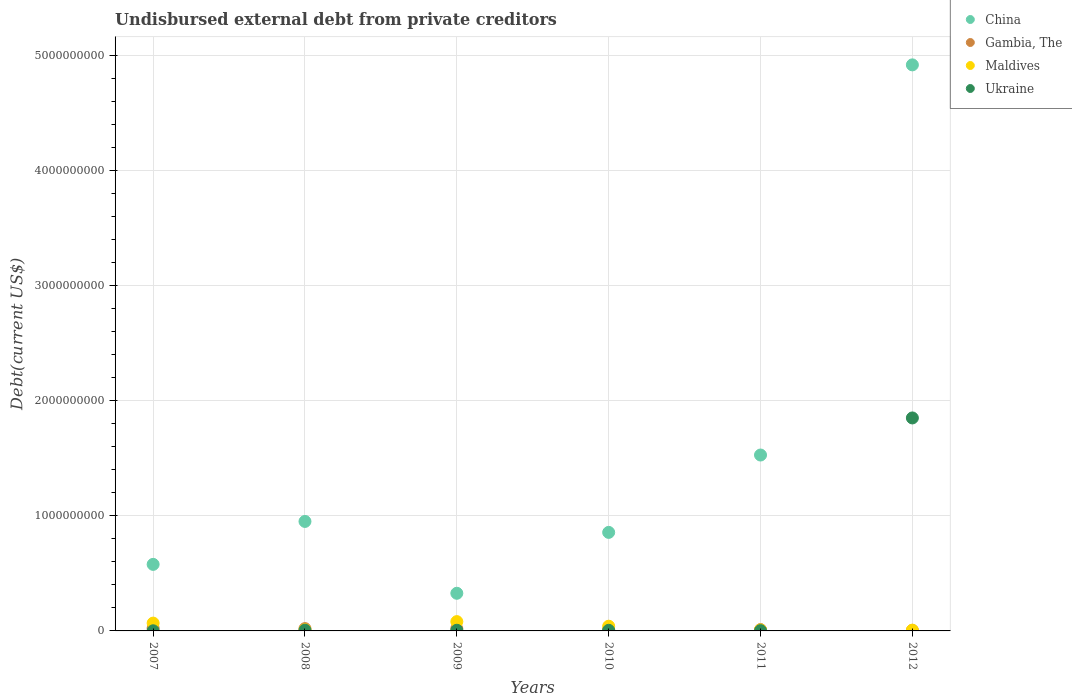What is the total debt in Maldives in 2012?
Your answer should be very brief. 6.80e+06. Across all years, what is the maximum total debt in Ukraine?
Ensure brevity in your answer.  1.85e+09. Across all years, what is the minimum total debt in Maldives?
Your response must be concise. 6.80e+06. In which year was the total debt in Ukraine maximum?
Keep it short and to the point. 2012. What is the total total debt in Maldives in the graph?
Your response must be concise. 2.15e+08. What is the difference between the total debt in Ukraine in 2008 and that in 2010?
Your response must be concise. 1.29e+06. What is the difference between the total debt in Ukraine in 2010 and the total debt in Maldives in 2012?
Your response must be concise. -1.45e+06. What is the average total debt in Ukraine per year?
Provide a short and direct response. 3.12e+08. In the year 2010, what is the difference between the total debt in Ukraine and total debt in Maldives?
Provide a short and direct response. -3.56e+07. What is the ratio of the total debt in Maldives in 2007 to that in 2008?
Your answer should be very brief. 7. Is the difference between the total debt in Ukraine in 2008 and 2011 greater than the difference between the total debt in Maldives in 2008 and 2011?
Offer a terse response. Yes. What is the difference between the highest and the second highest total debt in Maldives?
Offer a terse response. 1.30e+07. What is the difference between the highest and the lowest total debt in Ukraine?
Your answer should be compact. 1.85e+09. In how many years, is the total debt in China greater than the average total debt in China taken over all years?
Make the answer very short. 2. Is it the case that in every year, the sum of the total debt in Ukraine and total debt in Maldives  is greater than the total debt in Gambia, The?
Give a very brief answer. No. Does the total debt in Ukraine monotonically increase over the years?
Your answer should be compact. No. Is the total debt in Maldives strictly greater than the total debt in China over the years?
Your answer should be compact. No. How many dotlines are there?
Your answer should be compact. 4. How many years are there in the graph?
Provide a succinct answer. 6. Are the values on the major ticks of Y-axis written in scientific E-notation?
Provide a short and direct response. No. What is the title of the graph?
Offer a very short reply. Undisbursed external debt from private creditors. Does "Arab World" appear as one of the legend labels in the graph?
Make the answer very short. No. What is the label or title of the Y-axis?
Your answer should be compact. Debt(current US$). What is the Debt(current US$) in China in 2007?
Give a very brief answer. 5.78e+08. What is the Debt(current US$) of Gambia, The in 2007?
Provide a short and direct response. 2.39e+07. What is the Debt(current US$) in Maldives in 2007?
Give a very brief answer. 6.79e+07. What is the Debt(current US$) in Ukraine in 2007?
Your answer should be compact. 1.13e+06. What is the Debt(current US$) in China in 2008?
Your answer should be very brief. 9.51e+08. What is the Debt(current US$) in Gambia, The in 2008?
Provide a short and direct response. 2.01e+07. What is the Debt(current US$) in Maldives in 2008?
Provide a short and direct response. 9.70e+06. What is the Debt(current US$) in Ukraine in 2008?
Make the answer very short. 6.63e+06. What is the Debt(current US$) of China in 2009?
Offer a terse response. 3.27e+08. What is the Debt(current US$) in Gambia, The in 2009?
Offer a very short reply. 2.00e+07. What is the Debt(current US$) of Maldives in 2009?
Your response must be concise. 8.09e+07. What is the Debt(current US$) in Ukraine in 2009?
Your response must be concise. 5.76e+06. What is the Debt(current US$) of China in 2010?
Keep it short and to the point. 8.56e+08. What is the Debt(current US$) in Gambia, The in 2010?
Your response must be concise. 1.21e+07. What is the Debt(current US$) in Maldives in 2010?
Ensure brevity in your answer.  4.10e+07. What is the Debt(current US$) of Ukraine in 2010?
Provide a succinct answer. 5.34e+06. What is the Debt(current US$) of China in 2011?
Give a very brief answer. 1.53e+09. What is the Debt(current US$) in Gambia, The in 2011?
Keep it short and to the point. 1.17e+07. What is the Debt(current US$) of Maldives in 2011?
Your answer should be compact. 8.25e+06. What is the Debt(current US$) of Ukraine in 2011?
Provide a short and direct response. 2.59e+06. What is the Debt(current US$) in China in 2012?
Provide a succinct answer. 4.92e+09. What is the Debt(current US$) in Gambia, The in 2012?
Provide a short and direct response. 4.34e+06. What is the Debt(current US$) of Maldives in 2012?
Your response must be concise. 6.80e+06. What is the Debt(current US$) in Ukraine in 2012?
Offer a terse response. 1.85e+09. Across all years, what is the maximum Debt(current US$) of China?
Provide a short and direct response. 4.92e+09. Across all years, what is the maximum Debt(current US$) in Gambia, The?
Give a very brief answer. 2.39e+07. Across all years, what is the maximum Debt(current US$) of Maldives?
Ensure brevity in your answer.  8.09e+07. Across all years, what is the maximum Debt(current US$) in Ukraine?
Your answer should be very brief. 1.85e+09. Across all years, what is the minimum Debt(current US$) of China?
Your answer should be compact. 3.27e+08. Across all years, what is the minimum Debt(current US$) of Gambia, The?
Provide a succinct answer. 4.34e+06. Across all years, what is the minimum Debt(current US$) in Maldives?
Offer a terse response. 6.80e+06. Across all years, what is the minimum Debt(current US$) of Ukraine?
Your answer should be compact. 1.13e+06. What is the total Debt(current US$) of China in the graph?
Give a very brief answer. 9.16e+09. What is the total Debt(current US$) of Gambia, The in the graph?
Provide a short and direct response. 9.21e+07. What is the total Debt(current US$) of Maldives in the graph?
Provide a short and direct response. 2.15e+08. What is the total Debt(current US$) in Ukraine in the graph?
Your answer should be very brief. 1.87e+09. What is the difference between the Debt(current US$) of China in 2007 and that in 2008?
Offer a terse response. -3.73e+08. What is the difference between the Debt(current US$) in Gambia, The in 2007 and that in 2008?
Provide a succinct answer. 3.83e+06. What is the difference between the Debt(current US$) in Maldives in 2007 and that in 2008?
Make the answer very short. 5.82e+07. What is the difference between the Debt(current US$) of Ukraine in 2007 and that in 2008?
Offer a terse response. -5.50e+06. What is the difference between the Debt(current US$) in China in 2007 and that in 2009?
Make the answer very short. 2.51e+08. What is the difference between the Debt(current US$) in Gambia, The in 2007 and that in 2009?
Offer a very short reply. 3.94e+06. What is the difference between the Debt(current US$) in Maldives in 2007 and that in 2009?
Offer a very short reply. -1.30e+07. What is the difference between the Debt(current US$) of Ukraine in 2007 and that in 2009?
Provide a short and direct response. -4.63e+06. What is the difference between the Debt(current US$) of China in 2007 and that in 2010?
Make the answer very short. -2.78e+08. What is the difference between the Debt(current US$) of Gambia, The in 2007 and that in 2010?
Offer a terse response. 1.18e+07. What is the difference between the Debt(current US$) in Maldives in 2007 and that in 2010?
Your answer should be compact. 2.70e+07. What is the difference between the Debt(current US$) of Ukraine in 2007 and that in 2010?
Ensure brevity in your answer.  -4.22e+06. What is the difference between the Debt(current US$) in China in 2007 and that in 2011?
Provide a short and direct response. -9.50e+08. What is the difference between the Debt(current US$) in Gambia, The in 2007 and that in 2011?
Provide a short and direct response. 1.22e+07. What is the difference between the Debt(current US$) of Maldives in 2007 and that in 2011?
Make the answer very short. 5.97e+07. What is the difference between the Debt(current US$) in Ukraine in 2007 and that in 2011?
Make the answer very short. -1.46e+06. What is the difference between the Debt(current US$) in China in 2007 and that in 2012?
Your answer should be very brief. -4.34e+09. What is the difference between the Debt(current US$) of Gambia, The in 2007 and that in 2012?
Your response must be concise. 1.96e+07. What is the difference between the Debt(current US$) of Maldives in 2007 and that in 2012?
Ensure brevity in your answer.  6.11e+07. What is the difference between the Debt(current US$) in Ukraine in 2007 and that in 2012?
Make the answer very short. -1.85e+09. What is the difference between the Debt(current US$) in China in 2008 and that in 2009?
Your answer should be very brief. 6.24e+08. What is the difference between the Debt(current US$) in Gambia, The in 2008 and that in 2009?
Your answer should be compact. 1.05e+05. What is the difference between the Debt(current US$) in Maldives in 2008 and that in 2009?
Give a very brief answer. -7.12e+07. What is the difference between the Debt(current US$) of Ukraine in 2008 and that in 2009?
Ensure brevity in your answer.  8.71e+05. What is the difference between the Debt(current US$) of China in 2008 and that in 2010?
Give a very brief answer. 9.51e+07. What is the difference between the Debt(current US$) of Gambia, The in 2008 and that in 2010?
Offer a terse response. 8.01e+06. What is the difference between the Debt(current US$) of Maldives in 2008 and that in 2010?
Your answer should be compact. -3.13e+07. What is the difference between the Debt(current US$) of Ukraine in 2008 and that in 2010?
Your answer should be compact. 1.29e+06. What is the difference between the Debt(current US$) in China in 2008 and that in 2011?
Provide a short and direct response. -5.77e+08. What is the difference between the Debt(current US$) in Gambia, The in 2008 and that in 2011?
Offer a terse response. 8.40e+06. What is the difference between the Debt(current US$) in Maldives in 2008 and that in 2011?
Provide a succinct answer. 1.45e+06. What is the difference between the Debt(current US$) in Ukraine in 2008 and that in 2011?
Provide a succinct answer. 4.04e+06. What is the difference between the Debt(current US$) in China in 2008 and that in 2012?
Your answer should be compact. -3.97e+09. What is the difference between the Debt(current US$) of Gambia, The in 2008 and that in 2012?
Offer a terse response. 1.58e+07. What is the difference between the Debt(current US$) of Maldives in 2008 and that in 2012?
Provide a succinct answer. 2.91e+06. What is the difference between the Debt(current US$) of Ukraine in 2008 and that in 2012?
Your response must be concise. -1.84e+09. What is the difference between the Debt(current US$) of China in 2009 and that in 2010?
Offer a very short reply. -5.29e+08. What is the difference between the Debt(current US$) of Gambia, The in 2009 and that in 2010?
Your answer should be very brief. 7.91e+06. What is the difference between the Debt(current US$) of Maldives in 2009 and that in 2010?
Ensure brevity in your answer.  3.99e+07. What is the difference between the Debt(current US$) in Ukraine in 2009 and that in 2010?
Provide a short and direct response. 4.17e+05. What is the difference between the Debt(current US$) in China in 2009 and that in 2011?
Your response must be concise. -1.20e+09. What is the difference between the Debt(current US$) in Gambia, The in 2009 and that in 2011?
Ensure brevity in your answer.  8.29e+06. What is the difference between the Debt(current US$) in Maldives in 2009 and that in 2011?
Your answer should be compact. 7.26e+07. What is the difference between the Debt(current US$) of Ukraine in 2009 and that in 2011?
Make the answer very short. 3.17e+06. What is the difference between the Debt(current US$) in China in 2009 and that in 2012?
Offer a terse response. -4.59e+09. What is the difference between the Debt(current US$) in Gambia, The in 2009 and that in 2012?
Give a very brief answer. 1.57e+07. What is the difference between the Debt(current US$) in Maldives in 2009 and that in 2012?
Offer a terse response. 7.41e+07. What is the difference between the Debt(current US$) in Ukraine in 2009 and that in 2012?
Ensure brevity in your answer.  -1.84e+09. What is the difference between the Debt(current US$) of China in 2010 and that in 2011?
Your answer should be very brief. -6.72e+08. What is the difference between the Debt(current US$) of Gambia, The in 2010 and that in 2011?
Offer a terse response. 3.83e+05. What is the difference between the Debt(current US$) of Maldives in 2010 and that in 2011?
Offer a terse response. 3.27e+07. What is the difference between the Debt(current US$) of Ukraine in 2010 and that in 2011?
Ensure brevity in your answer.  2.76e+06. What is the difference between the Debt(current US$) of China in 2010 and that in 2012?
Keep it short and to the point. -4.06e+09. What is the difference between the Debt(current US$) of Gambia, The in 2010 and that in 2012?
Ensure brevity in your answer.  7.74e+06. What is the difference between the Debt(current US$) in Maldives in 2010 and that in 2012?
Your answer should be compact. 3.42e+07. What is the difference between the Debt(current US$) in Ukraine in 2010 and that in 2012?
Keep it short and to the point. -1.84e+09. What is the difference between the Debt(current US$) of China in 2011 and that in 2012?
Your answer should be very brief. -3.39e+09. What is the difference between the Debt(current US$) of Gambia, The in 2011 and that in 2012?
Give a very brief answer. 7.36e+06. What is the difference between the Debt(current US$) of Maldives in 2011 and that in 2012?
Offer a terse response. 1.46e+06. What is the difference between the Debt(current US$) of Ukraine in 2011 and that in 2012?
Your answer should be very brief. -1.85e+09. What is the difference between the Debt(current US$) of China in 2007 and the Debt(current US$) of Gambia, The in 2008?
Offer a terse response. 5.58e+08. What is the difference between the Debt(current US$) in China in 2007 and the Debt(current US$) in Maldives in 2008?
Ensure brevity in your answer.  5.68e+08. What is the difference between the Debt(current US$) in China in 2007 and the Debt(current US$) in Ukraine in 2008?
Your answer should be very brief. 5.71e+08. What is the difference between the Debt(current US$) in Gambia, The in 2007 and the Debt(current US$) in Maldives in 2008?
Keep it short and to the point. 1.42e+07. What is the difference between the Debt(current US$) of Gambia, The in 2007 and the Debt(current US$) of Ukraine in 2008?
Provide a short and direct response. 1.73e+07. What is the difference between the Debt(current US$) of Maldives in 2007 and the Debt(current US$) of Ukraine in 2008?
Make the answer very short. 6.13e+07. What is the difference between the Debt(current US$) of China in 2007 and the Debt(current US$) of Gambia, The in 2009?
Provide a short and direct response. 5.58e+08. What is the difference between the Debt(current US$) of China in 2007 and the Debt(current US$) of Maldives in 2009?
Give a very brief answer. 4.97e+08. What is the difference between the Debt(current US$) in China in 2007 and the Debt(current US$) in Ukraine in 2009?
Your answer should be compact. 5.72e+08. What is the difference between the Debt(current US$) of Gambia, The in 2007 and the Debt(current US$) of Maldives in 2009?
Offer a terse response. -5.70e+07. What is the difference between the Debt(current US$) of Gambia, The in 2007 and the Debt(current US$) of Ukraine in 2009?
Provide a short and direct response. 1.82e+07. What is the difference between the Debt(current US$) of Maldives in 2007 and the Debt(current US$) of Ukraine in 2009?
Offer a terse response. 6.22e+07. What is the difference between the Debt(current US$) in China in 2007 and the Debt(current US$) in Gambia, The in 2010?
Make the answer very short. 5.66e+08. What is the difference between the Debt(current US$) of China in 2007 and the Debt(current US$) of Maldives in 2010?
Your answer should be compact. 5.37e+08. What is the difference between the Debt(current US$) in China in 2007 and the Debt(current US$) in Ukraine in 2010?
Your answer should be very brief. 5.73e+08. What is the difference between the Debt(current US$) of Gambia, The in 2007 and the Debt(current US$) of Maldives in 2010?
Provide a succinct answer. -1.70e+07. What is the difference between the Debt(current US$) of Gambia, The in 2007 and the Debt(current US$) of Ukraine in 2010?
Your answer should be very brief. 1.86e+07. What is the difference between the Debt(current US$) in Maldives in 2007 and the Debt(current US$) in Ukraine in 2010?
Offer a very short reply. 6.26e+07. What is the difference between the Debt(current US$) in China in 2007 and the Debt(current US$) in Gambia, The in 2011?
Offer a very short reply. 5.66e+08. What is the difference between the Debt(current US$) of China in 2007 and the Debt(current US$) of Maldives in 2011?
Provide a short and direct response. 5.70e+08. What is the difference between the Debt(current US$) in China in 2007 and the Debt(current US$) in Ukraine in 2011?
Your answer should be compact. 5.75e+08. What is the difference between the Debt(current US$) in Gambia, The in 2007 and the Debt(current US$) in Maldives in 2011?
Your answer should be very brief. 1.57e+07. What is the difference between the Debt(current US$) in Gambia, The in 2007 and the Debt(current US$) in Ukraine in 2011?
Offer a very short reply. 2.13e+07. What is the difference between the Debt(current US$) of Maldives in 2007 and the Debt(current US$) of Ukraine in 2011?
Provide a short and direct response. 6.54e+07. What is the difference between the Debt(current US$) of China in 2007 and the Debt(current US$) of Gambia, The in 2012?
Offer a terse response. 5.74e+08. What is the difference between the Debt(current US$) in China in 2007 and the Debt(current US$) in Maldives in 2012?
Provide a short and direct response. 5.71e+08. What is the difference between the Debt(current US$) in China in 2007 and the Debt(current US$) in Ukraine in 2012?
Your answer should be very brief. -1.27e+09. What is the difference between the Debt(current US$) of Gambia, The in 2007 and the Debt(current US$) of Maldives in 2012?
Give a very brief answer. 1.71e+07. What is the difference between the Debt(current US$) in Gambia, The in 2007 and the Debt(current US$) in Ukraine in 2012?
Offer a very short reply. -1.83e+09. What is the difference between the Debt(current US$) in Maldives in 2007 and the Debt(current US$) in Ukraine in 2012?
Provide a succinct answer. -1.78e+09. What is the difference between the Debt(current US$) in China in 2008 and the Debt(current US$) in Gambia, The in 2009?
Offer a very short reply. 9.31e+08. What is the difference between the Debt(current US$) in China in 2008 and the Debt(current US$) in Maldives in 2009?
Offer a very short reply. 8.70e+08. What is the difference between the Debt(current US$) of China in 2008 and the Debt(current US$) of Ukraine in 2009?
Your answer should be very brief. 9.45e+08. What is the difference between the Debt(current US$) in Gambia, The in 2008 and the Debt(current US$) in Maldives in 2009?
Provide a succinct answer. -6.08e+07. What is the difference between the Debt(current US$) in Gambia, The in 2008 and the Debt(current US$) in Ukraine in 2009?
Provide a succinct answer. 1.43e+07. What is the difference between the Debt(current US$) of Maldives in 2008 and the Debt(current US$) of Ukraine in 2009?
Offer a very short reply. 3.94e+06. What is the difference between the Debt(current US$) of China in 2008 and the Debt(current US$) of Gambia, The in 2010?
Your answer should be very brief. 9.39e+08. What is the difference between the Debt(current US$) of China in 2008 and the Debt(current US$) of Maldives in 2010?
Offer a very short reply. 9.10e+08. What is the difference between the Debt(current US$) of China in 2008 and the Debt(current US$) of Ukraine in 2010?
Keep it short and to the point. 9.46e+08. What is the difference between the Debt(current US$) of Gambia, The in 2008 and the Debt(current US$) of Maldives in 2010?
Ensure brevity in your answer.  -2.09e+07. What is the difference between the Debt(current US$) of Gambia, The in 2008 and the Debt(current US$) of Ukraine in 2010?
Provide a short and direct response. 1.48e+07. What is the difference between the Debt(current US$) in Maldives in 2008 and the Debt(current US$) in Ukraine in 2010?
Give a very brief answer. 4.36e+06. What is the difference between the Debt(current US$) of China in 2008 and the Debt(current US$) of Gambia, The in 2011?
Give a very brief answer. 9.39e+08. What is the difference between the Debt(current US$) of China in 2008 and the Debt(current US$) of Maldives in 2011?
Give a very brief answer. 9.43e+08. What is the difference between the Debt(current US$) in China in 2008 and the Debt(current US$) in Ukraine in 2011?
Your response must be concise. 9.48e+08. What is the difference between the Debt(current US$) in Gambia, The in 2008 and the Debt(current US$) in Maldives in 2011?
Your answer should be very brief. 1.18e+07. What is the difference between the Debt(current US$) of Gambia, The in 2008 and the Debt(current US$) of Ukraine in 2011?
Keep it short and to the point. 1.75e+07. What is the difference between the Debt(current US$) in Maldives in 2008 and the Debt(current US$) in Ukraine in 2011?
Give a very brief answer. 7.12e+06. What is the difference between the Debt(current US$) in China in 2008 and the Debt(current US$) in Gambia, The in 2012?
Provide a succinct answer. 9.47e+08. What is the difference between the Debt(current US$) of China in 2008 and the Debt(current US$) of Maldives in 2012?
Your answer should be very brief. 9.44e+08. What is the difference between the Debt(current US$) in China in 2008 and the Debt(current US$) in Ukraine in 2012?
Offer a terse response. -8.99e+08. What is the difference between the Debt(current US$) of Gambia, The in 2008 and the Debt(current US$) of Maldives in 2012?
Your answer should be very brief. 1.33e+07. What is the difference between the Debt(current US$) in Gambia, The in 2008 and the Debt(current US$) in Ukraine in 2012?
Provide a succinct answer. -1.83e+09. What is the difference between the Debt(current US$) in Maldives in 2008 and the Debt(current US$) in Ukraine in 2012?
Your answer should be very brief. -1.84e+09. What is the difference between the Debt(current US$) in China in 2009 and the Debt(current US$) in Gambia, The in 2010?
Give a very brief answer. 3.15e+08. What is the difference between the Debt(current US$) of China in 2009 and the Debt(current US$) of Maldives in 2010?
Your response must be concise. 2.86e+08. What is the difference between the Debt(current US$) of China in 2009 and the Debt(current US$) of Ukraine in 2010?
Offer a terse response. 3.22e+08. What is the difference between the Debt(current US$) in Gambia, The in 2009 and the Debt(current US$) in Maldives in 2010?
Your answer should be very brief. -2.10e+07. What is the difference between the Debt(current US$) of Gambia, The in 2009 and the Debt(current US$) of Ukraine in 2010?
Give a very brief answer. 1.46e+07. What is the difference between the Debt(current US$) of Maldives in 2009 and the Debt(current US$) of Ukraine in 2010?
Your answer should be very brief. 7.56e+07. What is the difference between the Debt(current US$) in China in 2009 and the Debt(current US$) in Gambia, The in 2011?
Give a very brief answer. 3.15e+08. What is the difference between the Debt(current US$) in China in 2009 and the Debt(current US$) in Maldives in 2011?
Provide a succinct answer. 3.19e+08. What is the difference between the Debt(current US$) in China in 2009 and the Debt(current US$) in Ukraine in 2011?
Your answer should be compact. 3.24e+08. What is the difference between the Debt(current US$) in Gambia, The in 2009 and the Debt(current US$) in Maldives in 2011?
Keep it short and to the point. 1.17e+07. What is the difference between the Debt(current US$) of Gambia, The in 2009 and the Debt(current US$) of Ukraine in 2011?
Provide a short and direct response. 1.74e+07. What is the difference between the Debt(current US$) in Maldives in 2009 and the Debt(current US$) in Ukraine in 2011?
Ensure brevity in your answer.  7.83e+07. What is the difference between the Debt(current US$) in China in 2009 and the Debt(current US$) in Gambia, The in 2012?
Offer a terse response. 3.23e+08. What is the difference between the Debt(current US$) of China in 2009 and the Debt(current US$) of Maldives in 2012?
Provide a short and direct response. 3.20e+08. What is the difference between the Debt(current US$) of China in 2009 and the Debt(current US$) of Ukraine in 2012?
Offer a terse response. -1.52e+09. What is the difference between the Debt(current US$) in Gambia, The in 2009 and the Debt(current US$) in Maldives in 2012?
Provide a short and direct response. 1.32e+07. What is the difference between the Debt(current US$) in Gambia, The in 2009 and the Debt(current US$) in Ukraine in 2012?
Your response must be concise. -1.83e+09. What is the difference between the Debt(current US$) of Maldives in 2009 and the Debt(current US$) of Ukraine in 2012?
Your response must be concise. -1.77e+09. What is the difference between the Debt(current US$) in China in 2010 and the Debt(current US$) in Gambia, The in 2011?
Keep it short and to the point. 8.44e+08. What is the difference between the Debt(current US$) of China in 2010 and the Debt(current US$) of Maldives in 2011?
Make the answer very short. 8.48e+08. What is the difference between the Debt(current US$) in China in 2010 and the Debt(current US$) in Ukraine in 2011?
Make the answer very short. 8.53e+08. What is the difference between the Debt(current US$) in Gambia, The in 2010 and the Debt(current US$) in Maldives in 2011?
Keep it short and to the point. 3.83e+06. What is the difference between the Debt(current US$) of Gambia, The in 2010 and the Debt(current US$) of Ukraine in 2011?
Give a very brief answer. 9.49e+06. What is the difference between the Debt(current US$) of Maldives in 2010 and the Debt(current US$) of Ukraine in 2011?
Offer a very short reply. 3.84e+07. What is the difference between the Debt(current US$) of China in 2010 and the Debt(current US$) of Gambia, The in 2012?
Your answer should be compact. 8.52e+08. What is the difference between the Debt(current US$) of China in 2010 and the Debt(current US$) of Maldives in 2012?
Provide a succinct answer. 8.49e+08. What is the difference between the Debt(current US$) in China in 2010 and the Debt(current US$) in Ukraine in 2012?
Ensure brevity in your answer.  -9.94e+08. What is the difference between the Debt(current US$) of Gambia, The in 2010 and the Debt(current US$) of Maldives in 2012?
Ensure brevity in your answer.  5.29e+06. What is the difference between the Debt(current US$) of Gambia, The in 2010 and the Debt(current US$) of Ukraine in 2012?
Offer a terse response. -1.84e+09. What is the difference between the Debt(current US$) of Maldives in 2010 and the Debt(current US$) of Ukraine in 2012?
Provide a short and direct response. -1.81e+09. What is the difference between the Debt(current US$) in China in 2011 and the Debt(current US$) in Gambia, The in 2012?
Your response must be concise. 1.52e+09. What is the difference between the Debt(current US$) of China in 2011 and the Debt(current US$) of Maldives in 2012?
Your response must be concise. 1.52e+09. What is the difference between the Debt(current US$) in China in 2011 and the Debt(current US$) in Ukraine in 2012?
Your answer should be very brief. -3.22e+08. What is the difference between the Debt(current US$) in Gambia, The in 2011 and the Debt(current US$) in Maldives in 2012?
Your answer should be very brief. 4.90e+06. What is the difference between the Debt(current US$) in Gambia, The in 2011 and the Debt(current US$) in Ukraine in 2012?
Offer a terse response. -1.84e+09. What is the difference between the Debt(current US$) in Maldives in 2011 and the Debt(current US$) in Ukraine in 2012?
Offer a terse response. -1.84e+09. What is the average Debt(current US$) in China per year?
Give a very brief answer. 1.53e+09. What is the average Debt(current US$) of Gambia, The per year?
Your response must be concise. 1.54e+07. What is the average Debt(current US$) in Maldives per year?
Give a very brief answer. 3.58e+07. What is the average Debt(current US$) in Ukraine per year?
Ensure brevity in your answer.  3.12e+08. In the year 2007, what is the difference between the Debt(current US$) of China and Debt(current US$) of Gambia, The?
Ensure brevity in your answer.  5.54e+08. In the year 2007, what is the difference between the Debt(current US$) in China and Debt(current US$) in Maldives?
Ensure brevity in your answer.  5.10e+08. In the year 2007, what is the difference between the Debt(current US$) of China and Debt(current US$) of Ukraine?
Your answer should be compact. 5.77e+08. In the year 2007, what is the difference between the Debt(current US$) of Gambia, The and Debt(current US$) of Maldives?
Offer a terse response. -4.40e+07. In the year 2007, what is the difference between the Debt(current US$) in Gambia, The and Debt(current US$) in Ukraine?
Offer a terse response. 2.28e+07. In the year 2007, what is the difference between the Debt(current US$) of Maldives and Debt(current US$) of Ukraine?
Offer a very short reply. 6.68e+07. In the year 2008, what is the difference between the Debt(current US$) of China and Debt(current US$) of Gambia, The?
Make the answer very short. 9.31e+08. In the year 2008, what is the difference between the Debt(current US$) in China and Debt(current US$) in Maldives?
Your answer should be very brief. 9.41e+08. In the year 2008, what is the difference between the Debt(current US$) in China and Debt(current US$) in Ukraine?
Give a very brief answer. 9.44e+08. In the year 2008, what is the difference between the Debt(current US$) in Gambia, The and Debt(current US$) in Maldives?
Your answer should be very brief. 1.04e+07. In the year 2008, what is the difference between the Debt(current US$) of Gambia, The and Debt(current US$) of Ukraine?
Your answer should be compact. 1.35e+07. In the year 2008, what is the difference between the Debt(current US$) of Maldives and Debt(current US$) of Ukraine?
Ensure brevity in your answer.  3.07e+06. In the year 2009, what is the difference between the Debt(current US$) of China and Debt(current US$) of Gambia, The?
Give a very brief answer. 3.07e+08. In the year 2009, what is the difference between the Debt(current US$) in China and Debt(current US$) in Maldives?
Keep it short and to the point. 2.46e+08. In the year 2009, what is the difference between the Debt(current US$) in China and Debt(current US$) in Ukraine?
Keep it short and to the point. 3.21e+08. In the year 2009, what is the difference between the Debt(current US$) of Gambia, The and Debt(current US$) of Maldives?
Offer a terse response. -6.09e+07. In the year 2009, what is the difference between the Debt(current US$) of Gambia, The and Debt(current US$) of Ukraine?
Your answer should be compact. 1.42e+07. In the year 2009, what is the difference between the Debt(current US$) in Maldives and Debt(current US$) in Ukraine?
Provide a succinct answer. 7.51e+07. In the year 2010, what is the difference between the Debt(current US$) of China and Debt(current US$) of Gambia, The?
Your answer should be compact. 8.44e+08. In the year 2010, what is the difference between the Debt(current US$) of China and Debt(current US$) of Maldives?
Give a very brief answer. 8.15e+08. In the year 2010, what is the difference between the Debt(current US$) in China and Debt(current US$) in Ukraine?
Your response must be concise. 8.51e+08. In the year 2010, what is the difference between the Debt(current US$) in Gambia, The and Debt(current US$) in Maldives?
Offer a terse response. -2.89e+07. In the year 2010, what is the difference between the Debt(current US$) in Gambia, The and Debt(current US$) in Ukraine?
Give a very brief answer. 6.74e+06. In the year 2010, what is the difference between the Debt(current US$) of Maldives and Debt(current US$) of Ukraine?
Make the answer very short. 3.56e+07. In the year 2011, what is the difference between the Debt(current US$) of China and Debt(current US$) of Gambia, The?
Offer a very short reply. 1.52e+09. In the year 2011, what is the difference between the Debt(current US$) of China and Debt(current US$) of Maldives?
Your answer should be compact. 1.52e+09. In the year 2011, what is the difference between the Debt(current US$) of China and Debt(current US$) of Ukraine?
Your answer should be very brief. 1.53e+09. In the year 2011, what is the difference between the Debt(current US$) in Gambia, The and Debt(current US$) in Maldives?
Make the answer very short. 3.44e+06. In the year 2011, what is the difference between the Debt(current US$) of Gambia, The and Debt(current US$) of Ukraine?
Ensure brevity in your answer.  9.11e+06. In the year 2011, what is the difference between the Debt(current US$) in Maldives and Debt(current US$) in Ukraine?
Provide a short and direct response. 5.67e+06. In the year 2012, what is the difference between the Debt(current US$) of China and Debt(current US$) of Gambia, The?
Your answer should be very brief. 4.91e+09. In the year 2012, what is the difference between the Debt(current US$) of China and Debt(current US$) of Maldives?
Give a very brief answer. 4.91e+09. In the year 2012, what is the difference between the Debt(current US$) in China and Debt(current US$) in Ukraine?
Make the answer very short. 3.07e+09. In the year 2012, what is the difference between the Debt(current US$) in Gambia, The and Debt(current US$) in Maldives?
Offer a very short reply. -2.46e+06. In the year 2012, what is the difference between the Debt(current US$) of Gambia, The and Debt(current US$) of Ukraine?
Your answer should be compact. -1.85e+09. In the year 2012, what is the difference between the Debt(current US$) in Maldives and Debt(current US$) in Ukraine?
Your answer should be very brief. -1.84e+09. What is the ratio of the Debt(current US$) in China in 2007 to that in 2008?
Give a very brief answer. 0.61. What is the ratio of the Debt(current US$) in Gambia, The in 2007 to that in 2008?
Give a very brief answer. 1.19. What is the ratio of the Debt(current US$) in Maldives in 2007 to that in 2008?
Provide a succinct answer. 7. What is the ratio of the Debt(current US$) in Ukraine in 2007 to that in 2008?
Your response must be concise. 0.17. What is the ratio of the Debt(current US$) in China in 2007 to that in 2009?
Provide a succinct answer. 1.77. What is the ratio of the Debt(current US$) of Gambia, The in 2007 to that in 2009?
Your answer should be compact. 1.2. What is the ratio of the Debt(current US$) in Maldives in 2007 to that in 2009?
Keep it short and to the point. 0.84. What is the ratio of the Debt(current US$) in Ukraine in 2007 to that in 2009?
Your answer should be compact. 0.2. What is the ratio of the Debt(current US$) in China in 2007 to that in 2010?
Your answer should be very brief. 0.68. What is the ratio of the Debt(current US$) of Gambia, The in 2007 to that in 2010?
Keep it short and to the point. 1.98. What is the ratio of the Debt(current US$) of Maldives in 2007 to that in 2010?
Your answer should be compact. 1.66. What is the ratio of the Debt(current US$) of Ukraine in 2007 to that in 2010?
Provide a succinct answer. 0.21. What is the ratio of the Debt(current US$) of China in 2007 to that in 2011?
Provide a short and direct response. 0.38. What is the ratio of the Debt(current US$) in Gambia, The in 2007 to that in 2011?
Your answer should be compact. 2.05. What is the ratio of the Debt(current US$) in Maldives in 2007 to that in 2011?
Make the answer very short. 8.23. What is the ratio of the Debt(current US$) of Ukraine in 2007 to that in 2011?
Give a very brief answer. 0.44. What is the ratio of the Debt(current US$) of China in 2007 to that in 2012?
Provide a short and direct response. 0.12. What is the ratio of the Debt(current US$) in Gambia, The in 2007 to that in 2012?
Offer a terse response. 5.52. What is the ratio of the Debt(current US$) in Maldives in 2007 to that in 2012?
Your answer should be very brief. 10. What is the ratio of the Debt(current US$) of Ukraine in 2007 to that in 2012?
Your response must be concise. 0. What is the ratio of the Debt(current US$) of China in 2008 to that in 2009?
Ensure brevity in your answer.  2.91. What is the ratio of the Debt(current US$) of Maldives in 2008 to that in 2009?
Keep it short and to the point. 0.12. What is the ratio of the Debt(current US$) of Ukraine in 2008 to that in 2009?
Offer a terse response. 1.15. What is the ratio of the Debt(current US$) in Gambia, The in 2008 to that in 2010?
Offer a very short reply. 1.66. What is the ratio of the Debt(current US$) in Maldives in 2008 to that in 2010?
Your response must be concise. 0.24. What is the ratio of the Debt(current US$) of Ukraine in 2008 to that in 2010?
Offer a very short reply. 1.24. What is the ratio of the Debt(current US$) of China in 2008 to that in 2011?
Provide a short and direct response. 0.62. What is the ratio of the Debt(current US$) in Gambia, The in 2008 to that in 2011?
Give a very brief answer. 1.72. What is the ratio of the Debt(current US$) in Maldives in 2008 to that in 2011?
Give a very brief answer. 1.18. What is the ratio of the Debt(current US$) in Ukraine in 2008 to that in 2011?
Your answer should be very brief. 2.56. What is the ratio of the Debt(current US$) in China in 2008 to that in 2012?
Your answer should be very brief. 0.19. What is the ratio of the Debt(current US$) in Gambia, The in 2008 to that in 2012?
Provide a succinct answer. 4.63. What is the ratio of the Debt(current US$) of Maldives in 2008 to that in 2012?
Your answer should be compact. 1.43. What is the ratio of the Debt(current US$) in Ukraine in 2008 to that in 2012?
Your answer should be very brief. 0. What is the ratio of the Debt(current US$) in China in 2009 to that in 2010?
Offer a terse response. 0.38. What is the ratio of the Debt(current US$) of Gambia, The in 2009 to that in 2010?
Ensure brevity in your answer.  1.65. What is the ratio of the Debt(current US$) of Maldives in 2009 to that in 2010?
Keep it short and to the point. 1.97. What is the ratio of the Debt(current US$) of Ukraine in 2009 to that in 2010?
Offer a terse response. 1.08. What is the ratio of the Debt(current US$) in China in 2009 to that in 2011?
Your answer should be very brief. 0.21. What is the ratio of the Debt(current US$) in Gambia, The in 2009 to that in 2011?
Provide a short and direct response. 1.71. What is the ratio of the Debt(current US$) in Maldives in 2009 to that in 2011?
Offer a very short reply. 9.8. What is the ratio of the Debt(current US$) in Ukraine in 2009 to that in 2011?
Ensure brevity in your answer.  2.23. What is the ratio of the Debt(current US$) in China in 2009 to that in 2012?
Provide a succinct answer. 0.07. What is the ratio of the Debt(current US$) of Gambia, The in 2009 to that in 2012?
Make the answer very short. 4.61. What is the ratio of the Debt(current US$) of Maldives in 2009 to that in 2012?
Keep it short and to the point. 11.91. What is the ratio of the Debt(current US$) of Ukraine in 2009 to that in 2012?
Your response must be concise. 0. What is the ratio of the Debt(current US$) of China in 2010 to that in 2011?
Keep it short and to the point. 0.56. What is the ratio of the Debt(current US$) of Gambia, The in 2010 to that in 2011?
Keep it short and to the point. 1.03. What is the ratio of the Debt(current US$) of Maldives in 2010 to that in 2011?
Offer a very short reply. 4.96. What is the ratio of the Debt(current US$) in Ukraine in 2010 to that in 2011?
Provide a short and direct response. 2.07. What is the ratio of the Debt(current US$) in China in 2010 to that in 2012?
Your response must be concise. 0.17. What is the ratio of the Debt(current US$) in Gambia, The in 2010 to that in 2012?
Your answer should be very brief. 2.78. What is the ratio of the Debt(current US$) in Maldives in 2010 to that in 2012?
Your answer should be very brief. 6.03. What is the ratio of the Debt(current US$) in Ukraine in 2010 to that in 2012?
Provide a short and direct response. 0. What is the ratio of the Debt(current US$) of China in 2011 to that in 2012?
Your answer should be very brief. 0.31. What is the ratio of the Debt(current US$) of Gambia, The in 2011 to that in 2012?
Offer a terse response. 2.7. What is the ratio of the Debt(current US$) in Maldives in 2011 to that in 2012?
Give a very brief answer. 1.21. What is the ratio of the Debt(current US$) of Ukraine in 2011 to that in 2012?
Your answer should be very brief. 0. What is the difference between the highest and the second highest Debt(current US$) of China?
Make the answer very short. 3.39e+09. What is the difference between the highest and the second highest Debt(current US$) of Gambia, The?
Give a very brief answer. 3.83e+06. What is the difference between the highest and the second highest Debt(current US$) of Maldives?
Provide a short and direct response. 1.30e+07. What is the difference between the highest and the second highest Debt(current US$) of Ukraine?
Your response must be concise. 1.84e+09. What is the difference between the highest and the lowest Debt(current US$) in China?
Provide a short and direct response. 4.59e+09. What is the difference between the highest and the lowest Debt(current US$) in Gambia, The?
Keep it short and to the point. 1.96e+07. What is the difference between the highest and the lowest Debt(current US$) in Maldives?
Offer a very short reply. 7.41e+07. What is the difference between the highest and the lowest Debt(current US$) in Ukraine?
Give a very brief answer. 1.85e+09. 